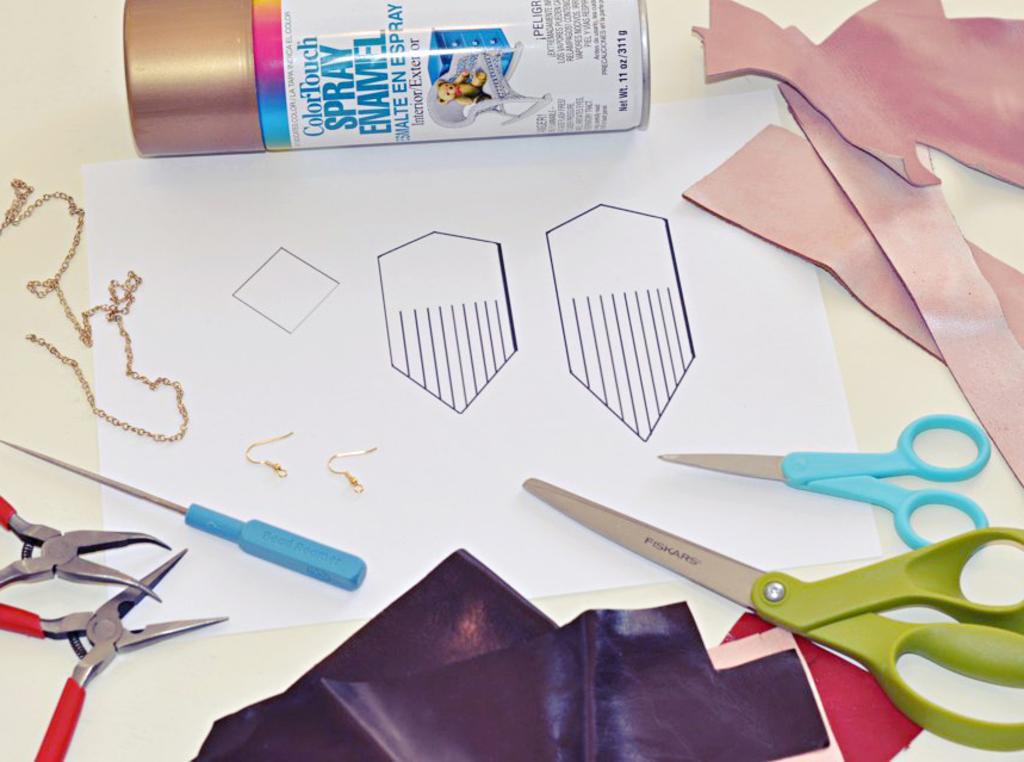Can you describe this image briefly? In this image there is a table and we can see papers, scissors, cutters, chains, spray bottle and an object placed on the table. 